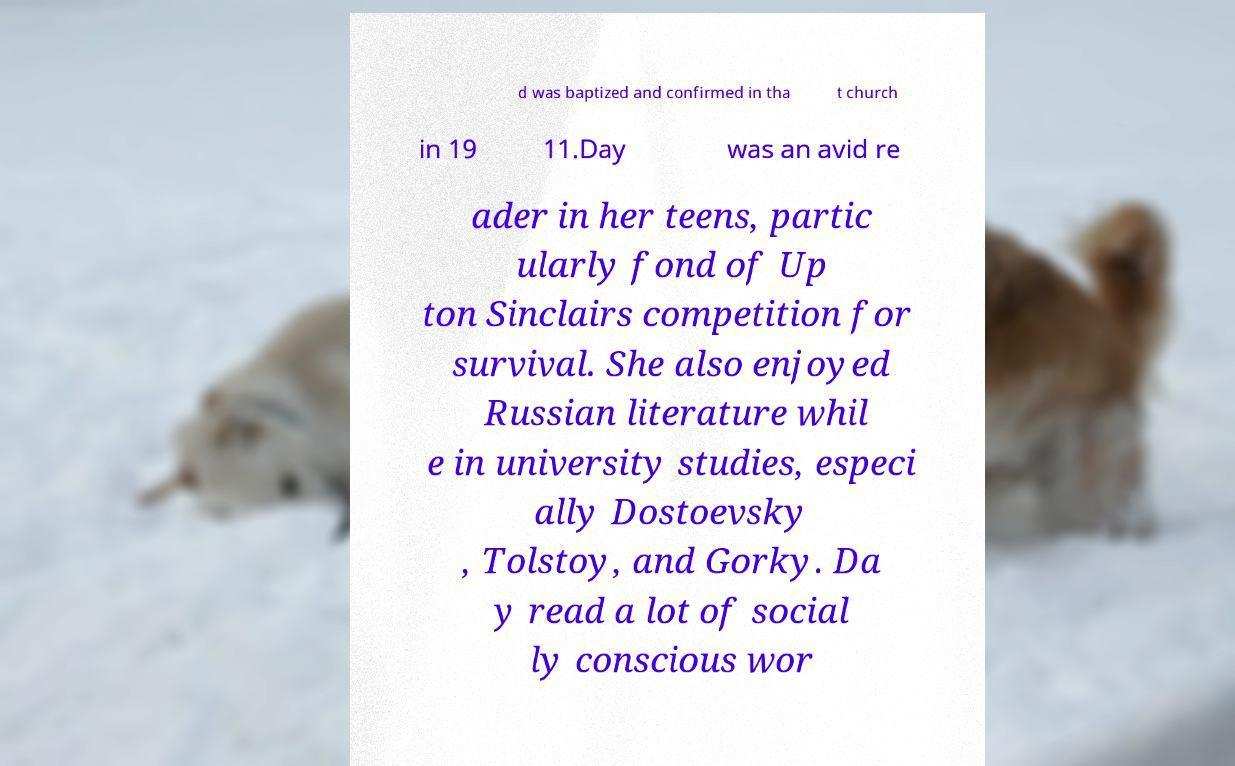Could you extract and type out the text from this image? d was baptized and confirmed in tha t church in 19 11.Day was an avid re ader in her teens, partic ularly fond of Up ton Sinclairs competition for survival. She also enjoyed Russian literature whil e in university studies, especi ally Dostoevsky , Tolstoy, and Gorky. Da y read a lot of social ly conscious wor 